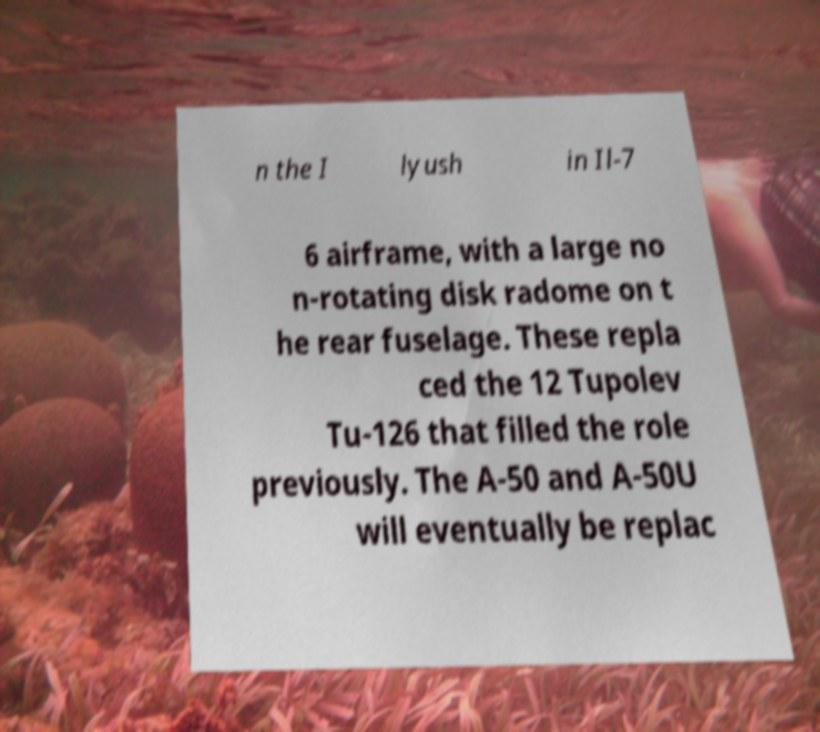There's text embedded in this image that I need extracted. Can you transcribe it verbatim? n the I lyush in Il-7 6 airframe, with a large no n-rotating disk radome on t he rear fuselage. These repla ced the 12 Tupolev Tu-126 that filled the role previously. The A-50 and A-50U will eventually be replac 